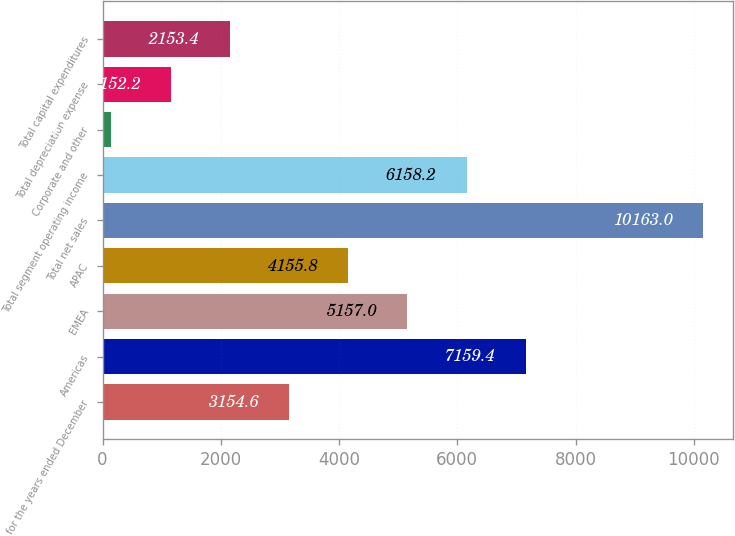<chart> <loc_0><loc_0><loc_500><loc_500><bar_chart><fcel>for the years ended December<fcel>Americas<fcel>EMEA<fcel>APAC<fcel>Total net sales<fcel>Total segment operating income<fcel>Corporate and other<fcel>Total depreciation expense<fcel>Total capital expenditures<nl><fcel>3154.6<fcel>7159.4<fcel>5157<fcel>4155.8<fcel>10163<fcel>6158.2<fcel>151<fcel>1152.2<fcel>2153.4<nl></chart> 